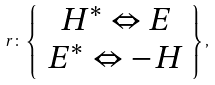Convert formula to latex. <formula><loc_0><loc_0><loc_500><loc_500>r \colon \left \{ \begin{array} { c } H ^ { \ast } \Leftrightarrow E \\ E ^ { \ast } \Leftrightarrow - H \end{array} \right \} ,</formula> 